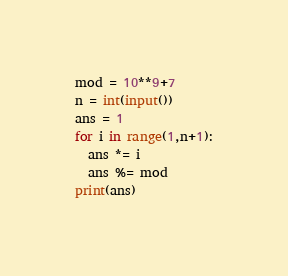<code> <loc_0><loc_0><loc_500><loc_500><_Python_>mod = 10**9+7
n = int(input())
ans = 1
for i in range(1,n+1):
  ans *= i
  ans %= mod
print(ans)</code> 